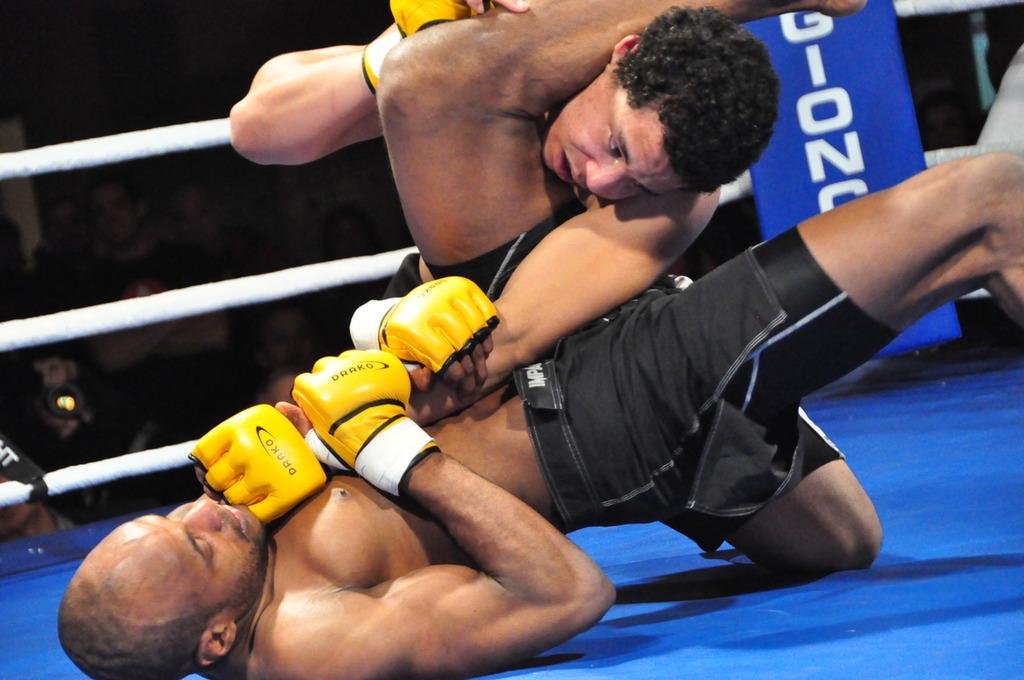What kind of gloves are the wrestlers wearing?
Your answer should be very brief. Drako. 